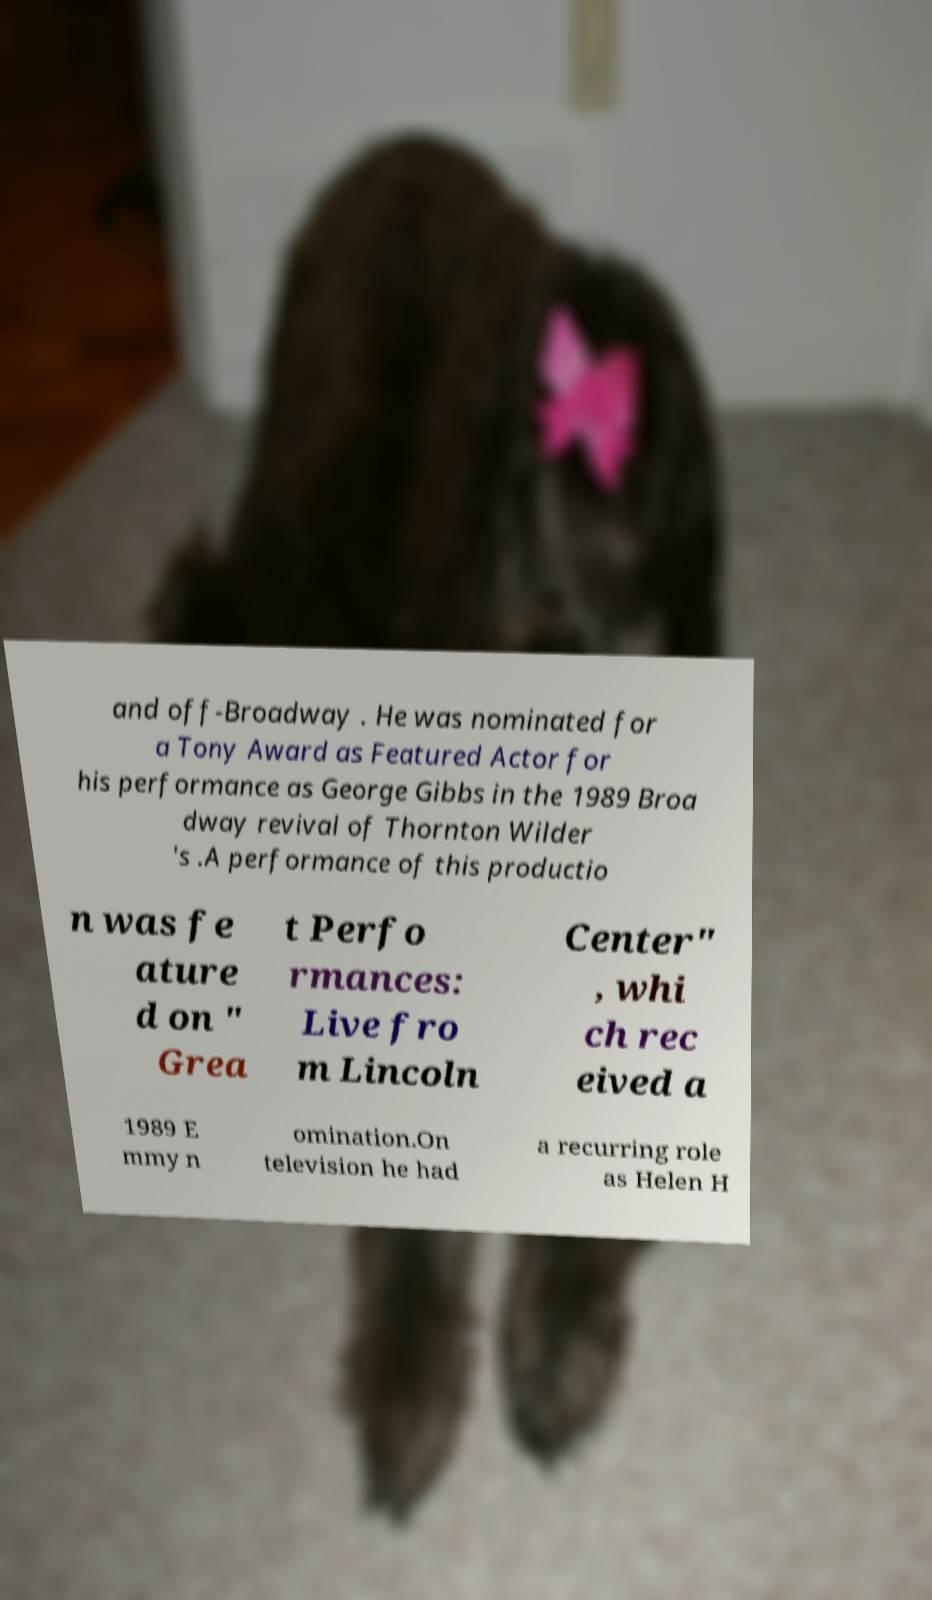Can you read and provide the text displayed in the image?This photo seems to have some interesting text. Can you extract and type it out for me? and off-Broadway . He was nominated for a Tony Award as Featured Actor for his performance as George Gibbs in the 1989 Broa dway revival of Thornton Wilder 's .A performance of this productio n was fe ature d on " Grea t Perfo rmances: Live fro m Lincoln Center" , whi ch rec eived a 1989 E mmy n omination.On television he had a recurring role as Helen H 